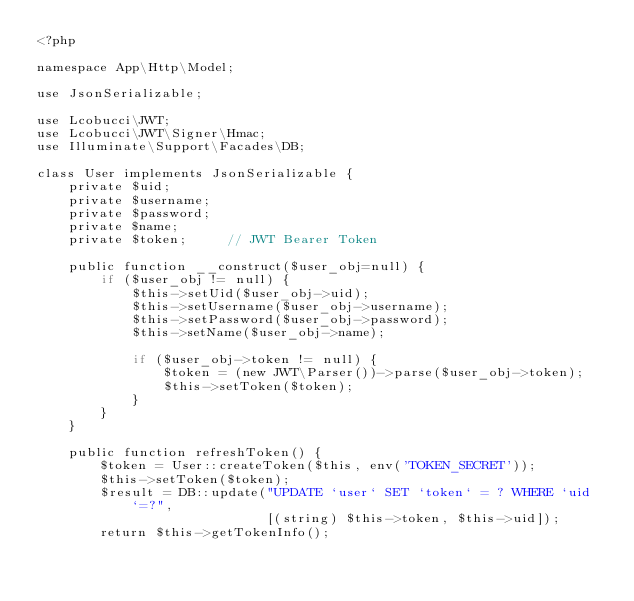Convert code to text. <code><loc_0><loc_0><loc_500><loc_500><_PHP_><?php

namespace App\Http\Model;

use JsonSerializable;

use Lcobucci\JWT;
use Lcobucci\JWT\Signer\Hmac;
use Illuminate\Support\Facades\DB;

class User implements JsonSerializable {
    private $uid;
    private $username;
    private $password;
    private $name;
    private $token;     // JWT Bearer Token

    public function __construct($user_obj=null) {
        if ($user_obj != null) {
            $this->setUid($user_obj->uid);
            $this->setUsername($user_obj->username);
            $this->setPassword($user_obj->password);
            $this->setName($user_obj->name);

            if ($user_obj->token != null) {
                $token = (new JWT\Parser())->parse($user_obj->token);
                $this->setToken($token);
            }
        }
    }

    public function refreshToken() {
        $token = User::createToken($this, env('TOKEN_SECRET'));
        $this->setToken($token);
        $result = DB::update("UPDATE `user` SET `token` = ? WHERE `uid`=?", 
                             [(string) $this->token, $this->uid]);
        return $this->getTokenInfo();</code> 